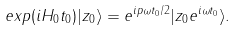<formula> <loc_0><loc_0><loc_500><loc_500>e x p ( i H _ { 0 } t _ { 0 } ) | z _ { 0 } \rangle = e ^ { i p \omega t _ { 0 } / 2 } | z _ { 0 } e ^ { i \omega t _ { 0 } } \rangle .</formula> 